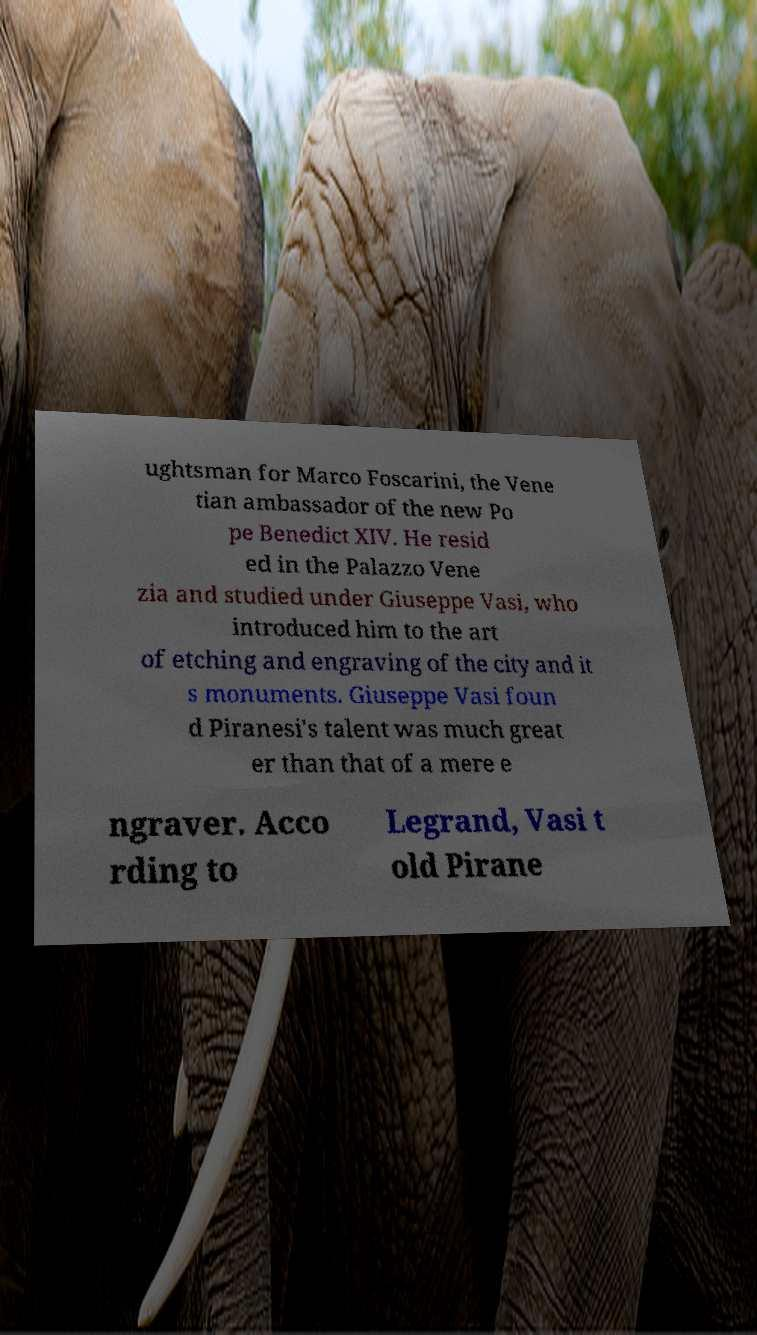Please identify and transcribe the text found in this image. ughtsman for Marco Foscarini, the Vene tian ambassador of the new Po pe Benedict XIV. He resid ed in the Palazzo Vene zia and studied under Giuseppe Vasi, who introduced him to the art of etching and engraving of the city and it s monuments. Giuseppe Vasi foun d Piranesi's talent was much great er than that of a mere e ngraver. Acco rding to Legrand, Vasi t old Pirane 